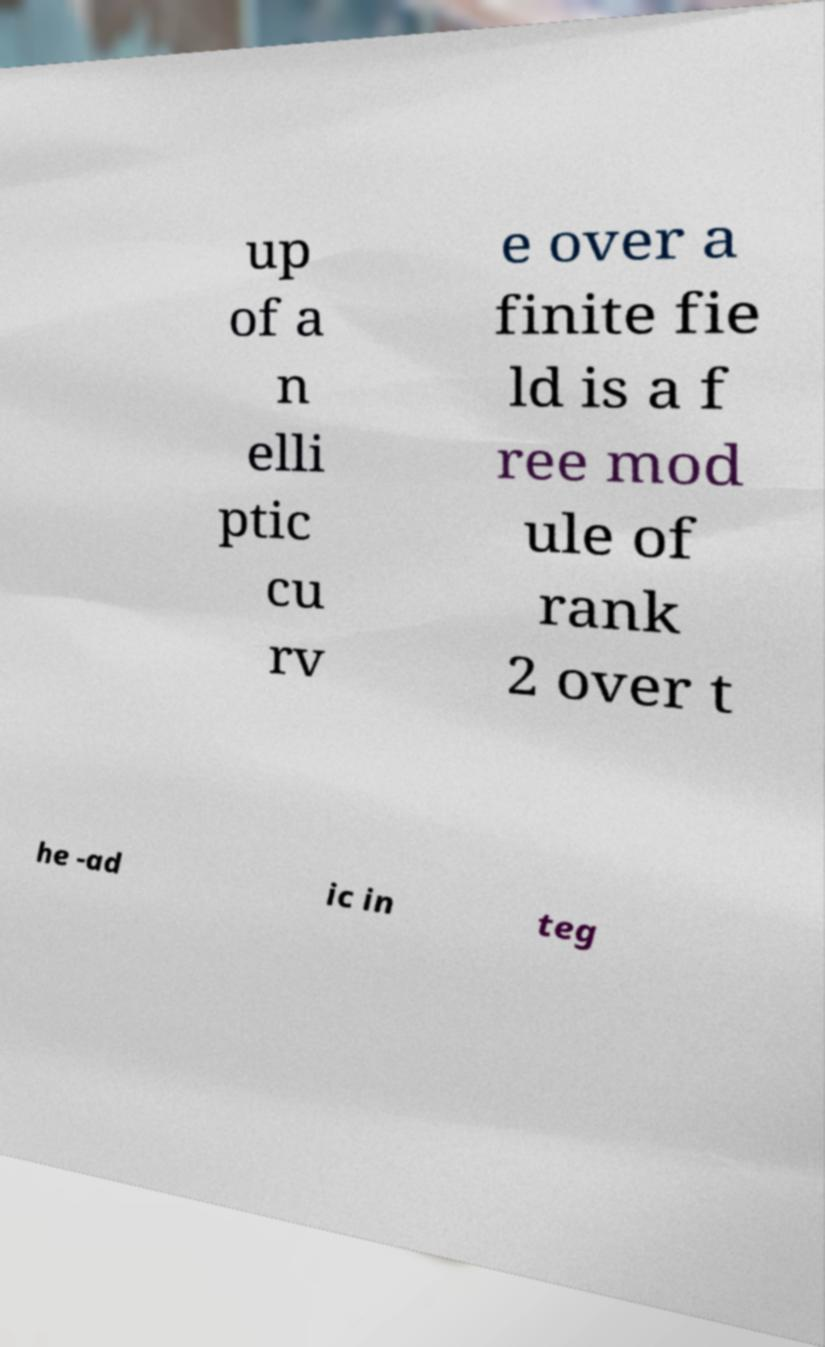I need the written content from this picture converted into text. Can you do that? up of a n elli ptic cu rv e over a finite fie ld is a f ree mod ule of rank 2 over t he -ad ic in teg 